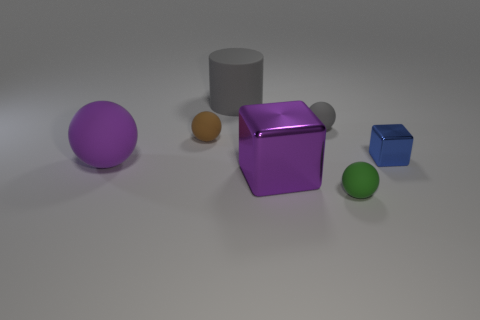Are there any things that have the same color as the big sphere?
Offer a terse response. Yes. What number of things are to the right of the large matte ball?
Ensure brevity in your answer.  6. The small thing that is to the right of the large gray matte cylinder and behind the small blue thing has what shape?
Provide a succinct answer. Sphere. There is a object that is the same color as the large rubber ball; what material is it?
Ensure brevity in your answer.  Metal. How many spheres are tiny red metal objects or purple matte things?
Offer a terse response. 1. What size is the ball that is the same color as the large metallic object?
Provide a short and direct response. Large. Is the number of purple blocks that are in front of the small green ball less than the number of cubes?
Your answer should be compact. Yes. What color is the small sphere that is both behind the big cube and to the right of the large gray cylinder?
Your answer should be compact. Gray. What number of other things are there of the same shape as the large metal object?
Your answer should be very brief. 1. Is the number of large purple objects that are behind the large purple matte object less than the number of gray spheres that are to the left of the small brown rubber object?
Provide a short and direct response. No. 